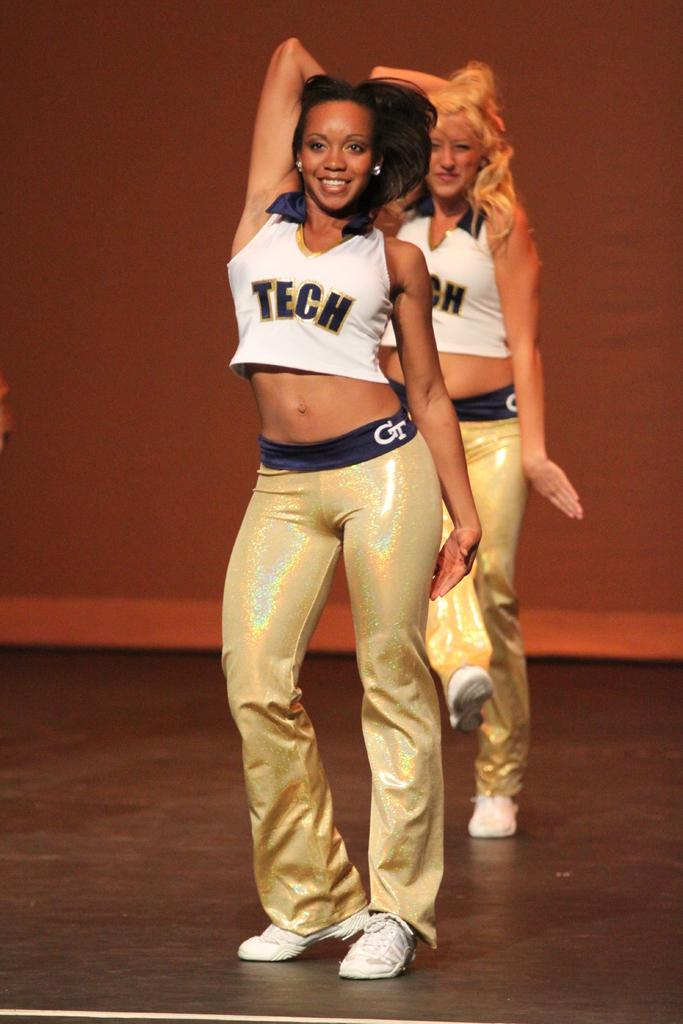<image>
Describe the image concisely. Two cheerleaders with TECH shirts on are doing a dance. 